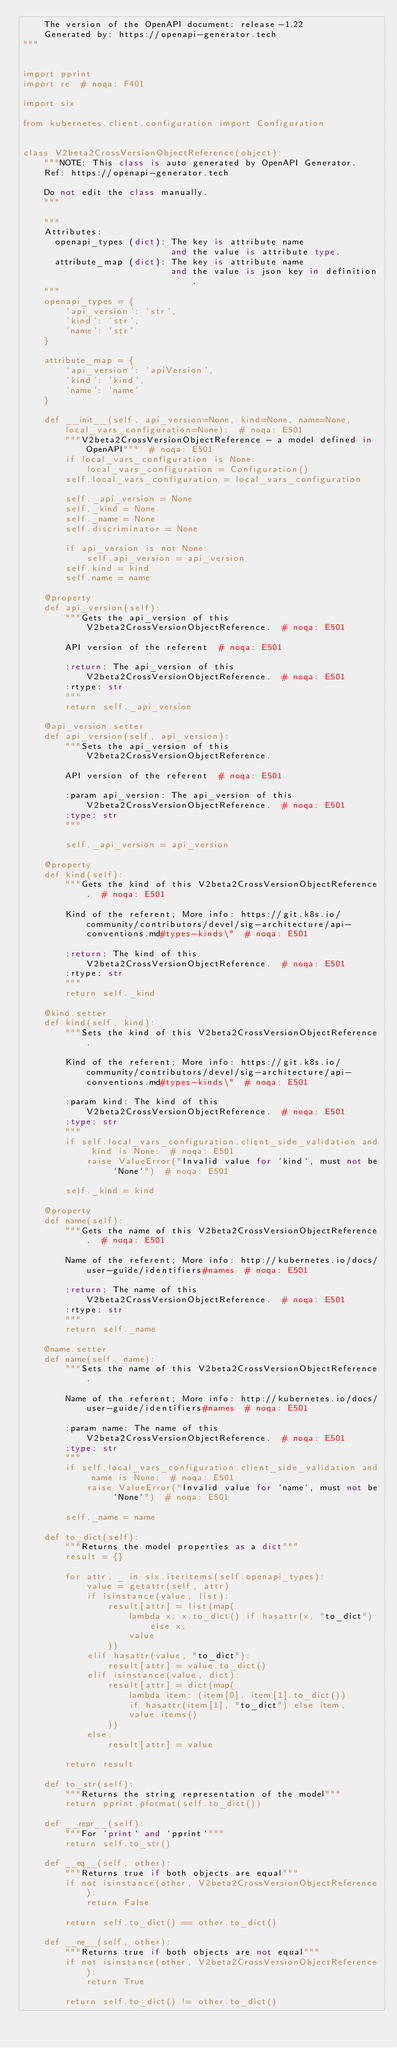Convert code to text. <code><loc_0><loc_0><loc_500><loc_500><_Python_>    The version of the OpenAPI document: release-1.22
    Generated by: https://openapi-generator.tech
"""


import pprint
import re  # noqa: F401

import six

from kubernetes.client.configuration import Configuration


class V2beta2CrossVersionObjectReference(object):
    """NOTE: This class is auto generated by OpenAPI Generator.
    Ref: https://openapi-generator.tech

    Do not edit the class manually.
    """

    """
    Attributes:
      openapi_types (dict): The key is attribute name
                            and the value is attribute type.
      attribute_map (dict): The key is attribute name
                            and the value is json key in definition.
    """
    openapi_types = {
        'api_version': 'str',
        'kind': 'str',
        'name': 'str'
    }

    attribute_map = {
        'api_version': 'apiVersion',
        'kind': 'kind',
        'name': 'name'
    }

    def __init__(self, api_version=None, kind=None, name=None, local_vars_configuration=None):  # noqa: E501
        """V2beta2CrossVersionObjectReference - a model defined in OpenAPI"""  # noqa: E501
        if local_vars_configuration is None:
            local_vars_configuration = Configuration()
        self.local_vars_configuration = local_vars_configuration

        self._api_version = None
        self._kind = None
        self._name = None
        self.discriminator = None

        if api_version is not None:
            self.api_version = api_version
        self.kind = kind
        self.name = name

    @property
    def api_version(self):
        """Gets the api_version of this V2beta2CrossVersionObjectReference.  # noqa: E501

        API version of the referent  # noqa: E501

        :return: The api_version of this V2beta2CrossVersionObjectReference.  # noqa: E501
        :rtype: str
        """
        return self._api_version

    @api_version.setter
    def api_version(self, api_version):
        """Sets the api_version of this V2beta2CrossVersionObjectReference.

        API version of the referent  # noqa: E501

        :param api_version: The api_version of this V2beta2CrossVersionObjectReference.  # noqa: E501
        :type: str
        """

        self._api_version = api_version

    @property
    def kind(self):
        """Gets the kind of this V2beta2CrossVersionObjectReference.  # noqa: E501

        Kind of the referent; More info: https://git.k8s.io/community/contributors/devel/sig-architecture/api-conventions.md#types-kinds\"  # noqa: E501

        :return: The kind of this V2beta2CrossVersionObjectReference.  # noqa: E501
        :rtype: str
        """
        return self._kind

    @kind.setter
    def kind(self, kind):
        """Sets the kind of this V2beta2CrossVersionObjectReference.

        Kind of the referent; More info: https://git.k8s.io/community/contributors/devel/sig-architecture/api-conventions.md#types-kinds\"  # noqa: E501

        :param kind: The kind of this V2beta2CrossVersionObjectReference.  # noqa: E501
        :type: str
        """
        if self.local_vars_configuration.client_side_validation and kind is None:  # noqa: E501
            raise ValueError("Invalid value for `kind`, must not be `None`")  # noqa: E501

        self._kind = kind

    @property
    def name(self):
        """Gets the name of this V2beta2CrossVersionObjectReference.  # noqa: E501

        Name of the referent; More info: http://kubernetes.io/docs/user-guide/identifiers#names  # noqa: E501

        :return: The name of this V2beta2CrossVersionObjectReference.  # noqa: E501
        :rtype: str
        """
        return self._name

    @name.setter
    def name(self, name):
        """Sets the name of this V2beta2CrossVersionObjectReference.

        Name of the referent; More info: http://kubernetes.io/docs/user-guide/identifiers#names  # noqa: E501

        :param name: The name of this V2beta2CrossVersionObjectReference.  # noqa: E501
        :type: str
        """
        if self.local_vars_configuration.client_side_validation and name is None:  # noqa: E501
            raise ValueError("Invalid value for `name`, must not be `None`")  # noqa: E501

        self._name = name

    def to_dict(self):
        """Returns the model properties as a dict"""
        result = {}

        for attr, _ in six.iteritems(self.openapi_types):
            value = getattr(self, attr)
            if isinstance(value, list):
                result[attr] = list(map(
                    lambda x: x.to_dict() if hasattr(x, "to_dict") else x,
                    value
                ))
            elif hasattr(value, "to_dict"):
                result[attr] = value.to_dict()
            elif isinstance(value, dict):
                result[attr] = dict(map(
                    lambda item: (item[0], item[1].to_dict())
                    if hasattr(item[1], "to_dict") else item,
                    value.items()
                ))
            else:
                result[attr] = value

        return result

    def to_str(self):
        """Returns the string representation of the model"""
        return pprint.pformat(self.to_dict())

    def __repr__(self):
        """For `print` and `pprint`"""
        return self.to_str()

    def __eq__(self, other):
        """Returns true if both objects are equal"""
        if not isinstance(other, V2beta2CrossVersionObjectReference):
            return False

        return self.to_dict() == other.to_dict()

    def __ne__(self, other):
        """Returns true if both objects are not equal"""
        if not isinstance(other, V2beta2CrossVersionObjectReference):
            return True

        return self.to_dict() != other.to_dict()
</code> 